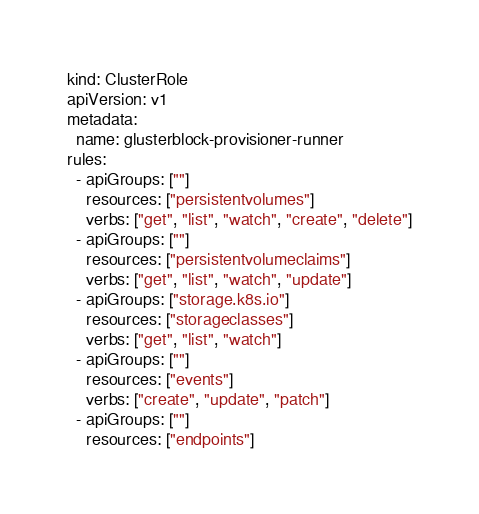Convert code to text. <code><loc_0><loc_0><loc_500><loc_500><_YAML_>kind: ClusterRole
apiVersion: v1
metadata:
  name: glusterblock-provisioner-runner
rules:
  - apiGroups: [""]
    resources: ["persistentvolumes"]
    verbs: ["get", "list", "watch", "create", "delete"]
  - apiGroups: [""]
    resources: ["persistentvolumeclaims"]
    verbs: ["get", "list", "watch", "update"]
  - apiGroups: ["storage.k8s.io"]
    resources: ["storageclasses"]
    verbs: ["get", "list", "watch"]
  - apiGroups: [""]
    resources: ["events"]
    verbs: ["create", "update", "patch"]
  - apiGroups: [""]
    resources: ["endpoints"]</code> 